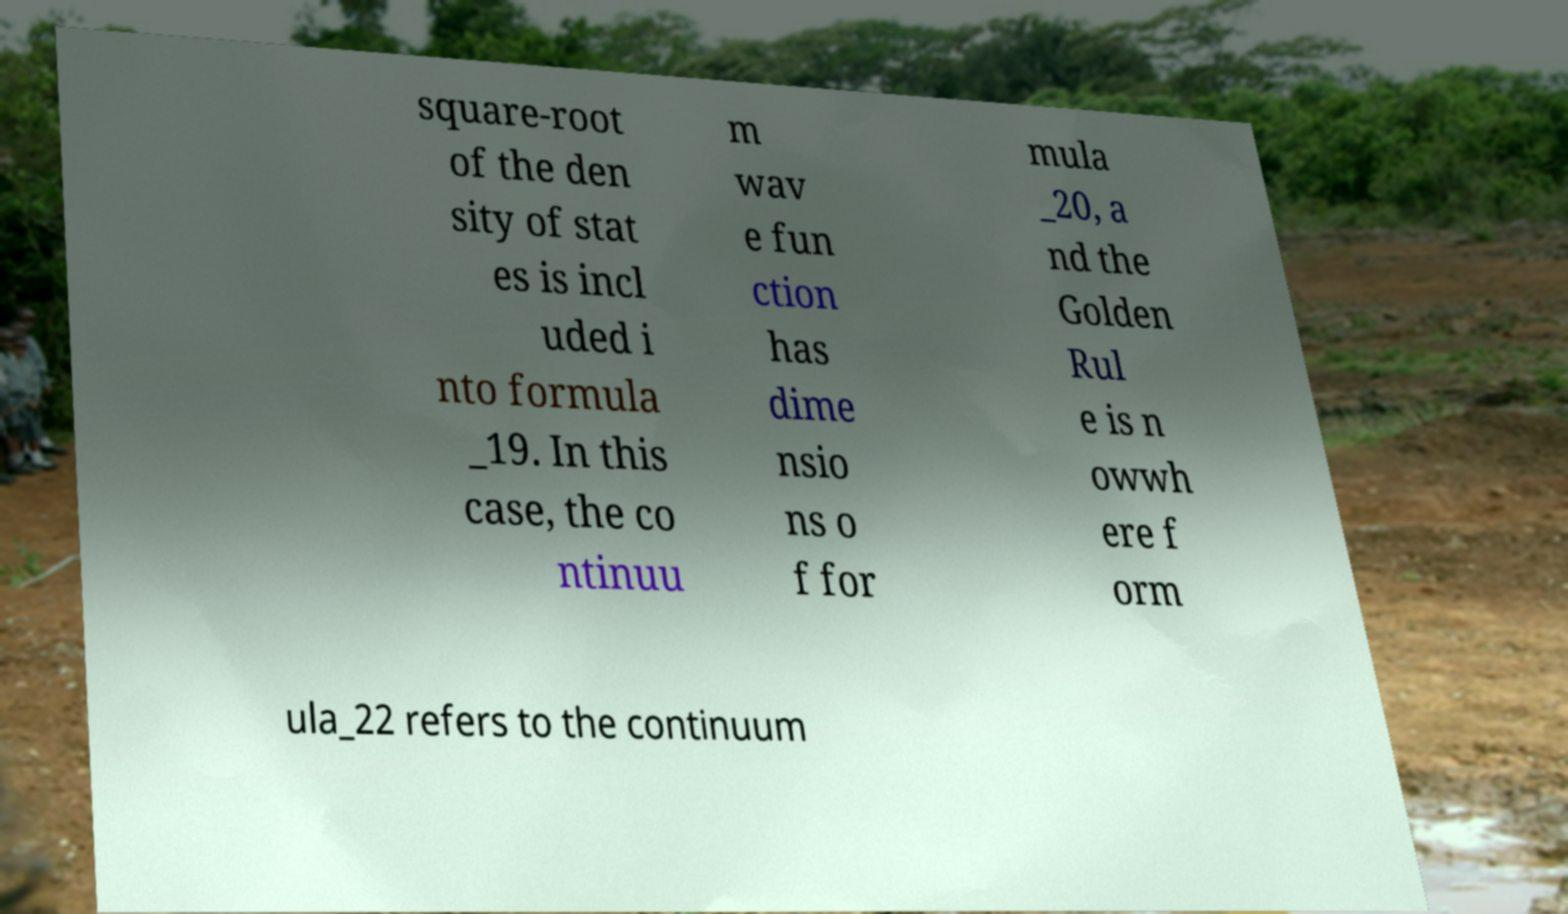Please identify and transcribe the text found in this image. square-root of the den sity of stat es is incl uded i nto formula _19. In this case, the co ntinuu m wav e fun ction has dime nsio ns o f for mula _20, a nd the Golden Rul e is n owwh ere f orm ula_22 refers to the continuum 